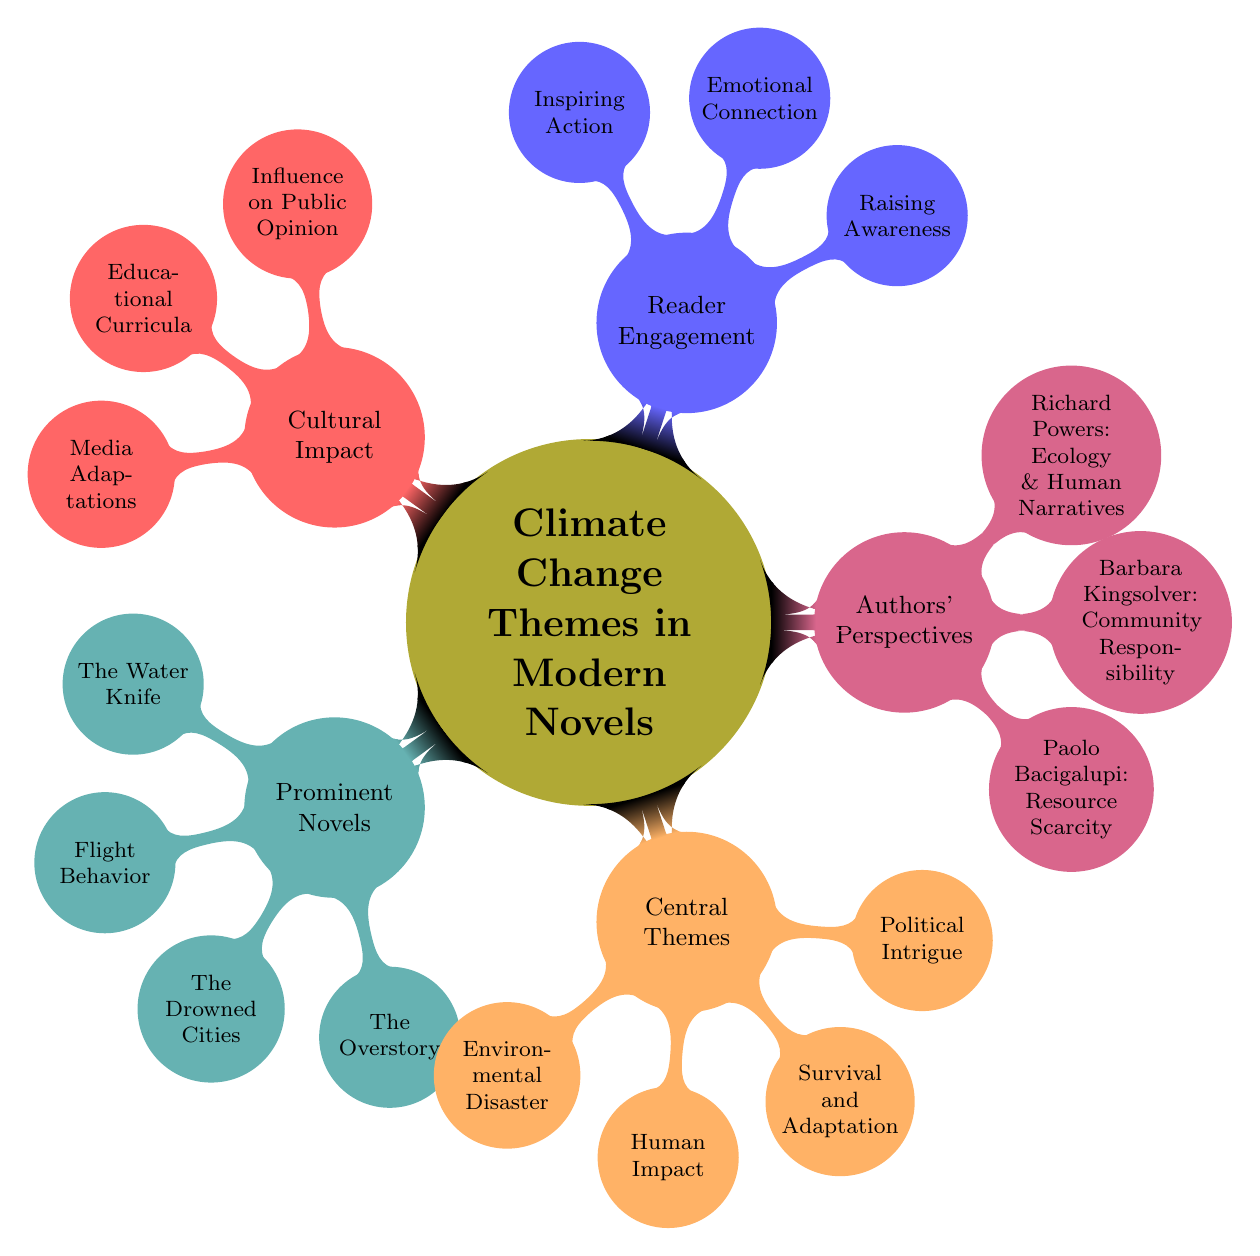What are the prominent novels listed in the diagram? The diagram specifically lists four novels as prominent: "The Water Knife," "Flight Behavior," "The Drowned Cities," and "The Overstory." This information can be found directly within the "Prominent Novels" subtopic.
Answer: The Water Knife, Flight Behavior, The Drowned Cities, The Overstory What is one of the central themes mentioned? In the "Central Themes" section, the diagram highlights four themes. Any of the following can be an answer: "Environmental Disaster," "Human Impact," "Survival and Adaptation," or "Political Intrigue." This is based on the direct listing under that subtopic.
Answer: Environmental Disaster How many authors' perspectives are detailed in the diagram? The diagram presents three distinct authors' perspectives under the "Authors' Perspectives" subtopic: Paolo Bacigalupi, Barbara Kingsolver, and Richard Powers. Therefore, the count is derived from the total sub-elements listed in that section.
Answer: 3 What is one aspect of reader engagement discussed? The diagram indicates three aspects of reader engagement: "Raising Awareness," "Emotional Connection," and "Inspiring Action." Each of these can be considered an answer because they are part of the same subtopic.
Answer: Raising Awareness Which author focuses on resource scarcity? According to the "Authors' Perspectives" section of the diagram, Paolo Bacigalupi's perspective specifically focuses on resource scarcity. This is directly stated next to his name in that part of the mind map.
Answer: Paolo Bacigalupi What is the relationship between cultural impact and public opinion? The diagram outlines cultural impact as one of the main themes and under it, "Influence on Public Opinion" is listed as one of the aspects. The relationship can be derived from the placement of these elements indicating that cultural impact encompasses the influence on public opinion.
Answer: Influence on Public Opinion Which novels are associated with the theme of "Survival and Adaptation"? The diagram does not explicitly link certain novels with specific themes, but "Survival and Adaptation" is one of the central themes. To answer this question thoroughly, one must cross-reference the prominent novels and their themes, but the diagram does not show a direct connection.
Answer: Not applicable In what ways do modern novels engage readers regarding climate change? The diagram lists three specific ways under "Reader Engagement": "Raising Awareness," "Emotional Connection," and "Inspiring Action." This presents a clear understanding of how novels can connect with their audience concerning climate change themes.
Answer: Raising Awareness, Emotional Connection, Inspiring Action 